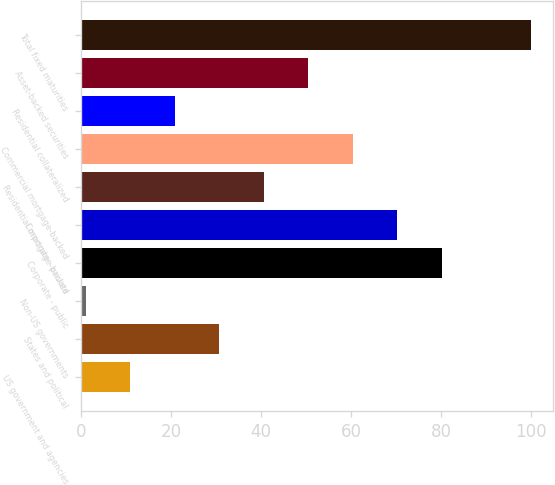<chart> <loc_0><loc_0><loc_500><loc_500><bar_chart><fcel>US government and agencies<fcel>States and political<fcel>Non-US governments<fcel>Corporate - public<fcel>Corporate - private<fcel>Residential mortgage-backed<fcel>Commercial mortgage-backed<fcel>Residential collateralized<fcel>Asset-backed securities<fcel>Total fixed maturities<nl><fcel>10.9<fcel>30.7<fcel>1<fcel>80.2<fcel>70.3<fcel>40.6<fcel>60.4<fcel>20.8<fcel>50.5<fcel>100<nl></chart> 